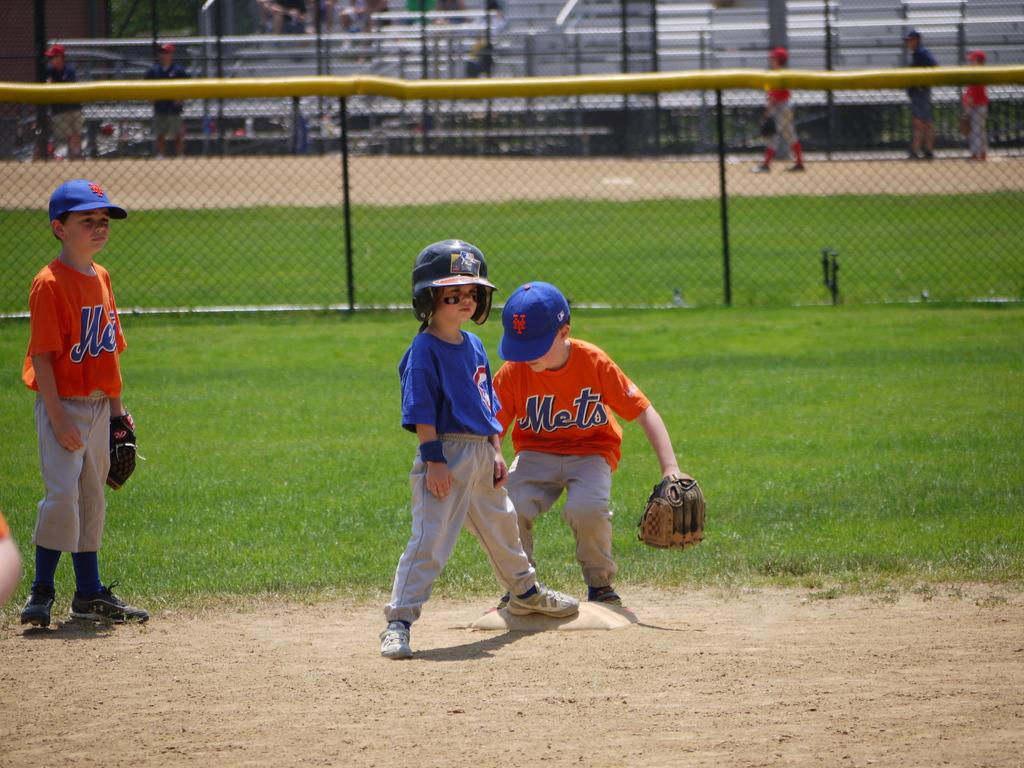<image>
Provide a brief description of the given image. Three little kids are playing baseball with one team being the Mets as seen on the two boys uniforms. 